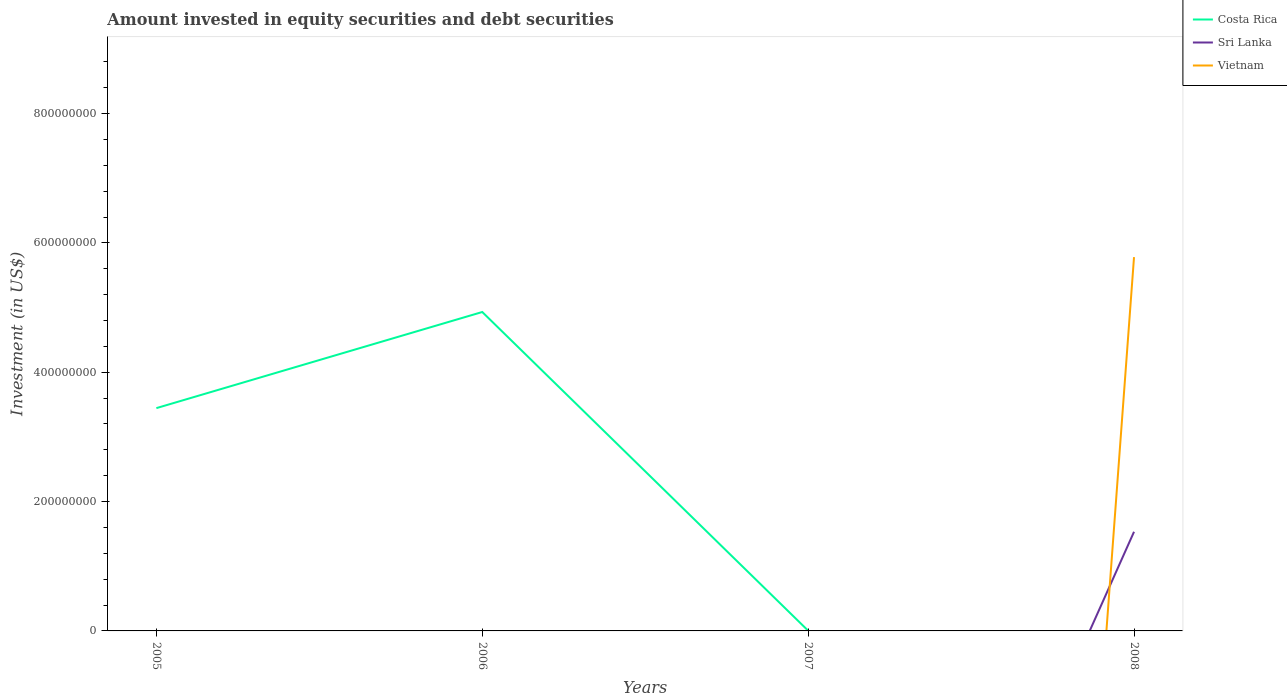How many different coloured lines are there?
Offer a terse response. 3. Does the line corresponding to Vietnam intersect with the line corresponding to Costa Rica?
Provide a short and direct response. Yes. What is the difference between the highest and the second highest amount invested in equity securities and debt securities in Costa Rica?
Provide a succinct answer. 4.93e+08. What is the difference between the highest and the lowest amount invested in equity securities and debt securities in Sri Lanka?
Offer a terse response. 1. How many lines are there?
Your answer should be very brief. 3. How many years are there in the graph?
Keep it short and to the point. 4. Where does the legend appear in the graph?
Offer a very short reply. Top right. How are the legend labels stacked?
Provide a succinct answer. Vertical. What is the title of the graph?
Your answer should be very brief. Amount invested in equity securities and debt securities. What is the label or title of the X-axis?
Make the answer very short. Years. What is the label or title of the Y-axis?
Ensure brevity in your answer.  Investment (in US$). What is the Investment (in US$) in Costa Rica in 2005?
Offer a terse response. 3.45e+08. What is the Investment (in US$) of Costa Rica in 2006?
Your answer should be very brief. 4.93e+08. What is the Investment (in US$) in Vietnam in 2006?
Provide a succinct answer. 0. What is the Investment (in US$) of Costa Rica in 2007?
Your answer should be very brief. 3.93e+05. What is the Investment (in US$) in Sri Lanka in 2007?
Give a very brief answer. 0. What is the Investment (in US$) in Costa Rica in 2008?
Make the answer very short. 0. What is the Investment (in US$) of Sri Lanka in 2008?
Keep it short and to the point. 1.53e+08. What is the Investment (in US$) in Vietnam in 2008?
Ensure brevity in your answer.  5.78e+08. Across all years, what is the maximum Investment (in US$) in Costa Rica?
Provide a succinct answer. 4.93e+08. Across all years, what is the maximum Investment (in US$) of Sri Lanka?
Give a very brief answer. 1.53e+08. Across all years, what is the maximum Investment (in US$) in Vietnam?
Your answer should be compact. 5.78e+08. Across all years, what is the minimum Investment (in US$) in Costa Rica?
Give a very brief answer. 0. What is the total Investment (in US$) of Costa Rica in the graph?
Offer a very short reply. 8.38e+08. What is the total Investment (in US$) of Sri Lanka in the graph?
Your response must be concise. 1.53e+08. What is the total Investment (in US$) in Vietnam in the graph?
Your response must be concise. 5.78e+08. What is the difference between the Investment (in US$) in Costa Rica in 2005 and that in 2006?
Ensure brevity in your answer.  -1.49e+08. What is the difference between the Investment (in US$) in Costa Rica in 2005 and that in 2007?
Your answer should be compact. 3.44e+08. What is the difference between the Investment (in US$) in Costa Rica in 2006 and that in 2007?
Your answer should be compact. 4.93e+08. What is the difference between the Investment (in US$) of Costa Rica in 2005 and the Investment (in US$) of Sri Lanka in 2008?
Offer a very short reply. 1.91e+08. What is the difference between the Investment (in US$) in Costa Rica in 2005 and the Investment (in US$) in Vietnam in 2008?
Provide a succinct answer. -2.33e+08. What is the difference between the Investment (in US$) in Costa Rica in 2006 and the Investment (in US$) in Sri Lanka in 2008?
Keep it short and to the point. 3.40e+08. What is the difference between the Investment (in US$) in Costa Rica in 2006 and the Investment (in US$) in Vietnam in 2008?
Your response must be concise. -8.49e+07. What is the difference between the Investment (in US$) in Costa Rica in 2007 and the Investment (in US$) in Sri Lanka in 2008?
Give a very brief answer. -1.53e+08. What is the difference between the Investment (in US$) of Costa Rica in 2007 and the Investment (in US$) of Vietnam in 2008?
Provide a short and direct response. -5.78e+08. What is the average Investment (in US$) of Costa Rica per year?
Provide a short and direct response. 2.10e+08. What is the average Investment (in US$) of Sri Lanka per year?
Offer a terse response. 3.83e+07. What is the average Investment (in US$) in Vietnam per year?
Make the answer very short. 1.44e+08. In the year 2008, what is the difference between the Investment (in US$) in Sri Lanka and Investment (in US$) in Vietnam?
Ensure brevity in your answer.  -4.25e+08. What is the ratio of the Investment (in US$) of Costa Rica in 2005 to that in 2006?
Give a very brief answer. 0.7. What is the ratio of the Investment (in US$) in Costa Rica in 2005 to that in 2007?
Provide a short and direct response. 877.69. What is the ratio of the Investment (in US$) in Costa Rica in 2006 to that in 2007?
Offer a terse response. 1256.35. What is the difference between the highest and the second highest Investment (in US$) in Costa Rica?
Offer a very short reply. 1.49e+08. What is the difference between the highest and the lowest Investment (in US$) in Costa Rica?
Keep it short and to the point. 4.93e+08. What is the difference between the highest and the lowest Investment (in US$) in Sri Lanka?
Your answer should be compact. 1.53e+08. What is the difference between the highest and the lowest Investment (in US$) of Vietnam?
Give a very brief answer. 5.78e+08. 